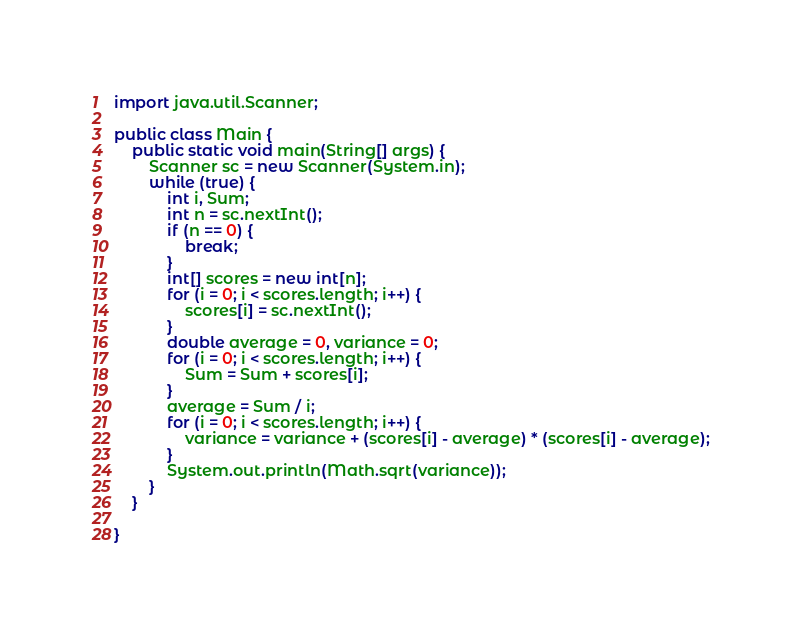Convert code to text. <code><loc_0><loc_0><loc_500><loc_500><_Java_>import java.util.Scanner;

public class Main {
	public static void main(String[] args) {
		Scanner sc = new Scanner(System.in);
		while (true) {
			int i, Sum;
			int n = sc.nextInt();
			if (n == 0) {
				break;
			}
			int[] scores = new int[n];
			for (i = 0; i < scores.length; i++) {
				scores[i] = sc.nextInt();
			}
			double average = 0, variance = 0;
			for (i = 0; i < scores.length; i++) {
				Sum = Sum + scores[i];
			}
			average = Sum / i;
			for (i = 0; i < scores.length; i++) {
				variance = variance + (scores[i] - average) * (scores[i] - average);
			}
			System.out.println(Math.sqrt(variance));
		}
	}

}</code> 